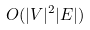Convert formula to latex. <formula><loc_0><loc_0><loc_500><loc_500>O ( | V | ^ { 2 } | E | )</formula> 